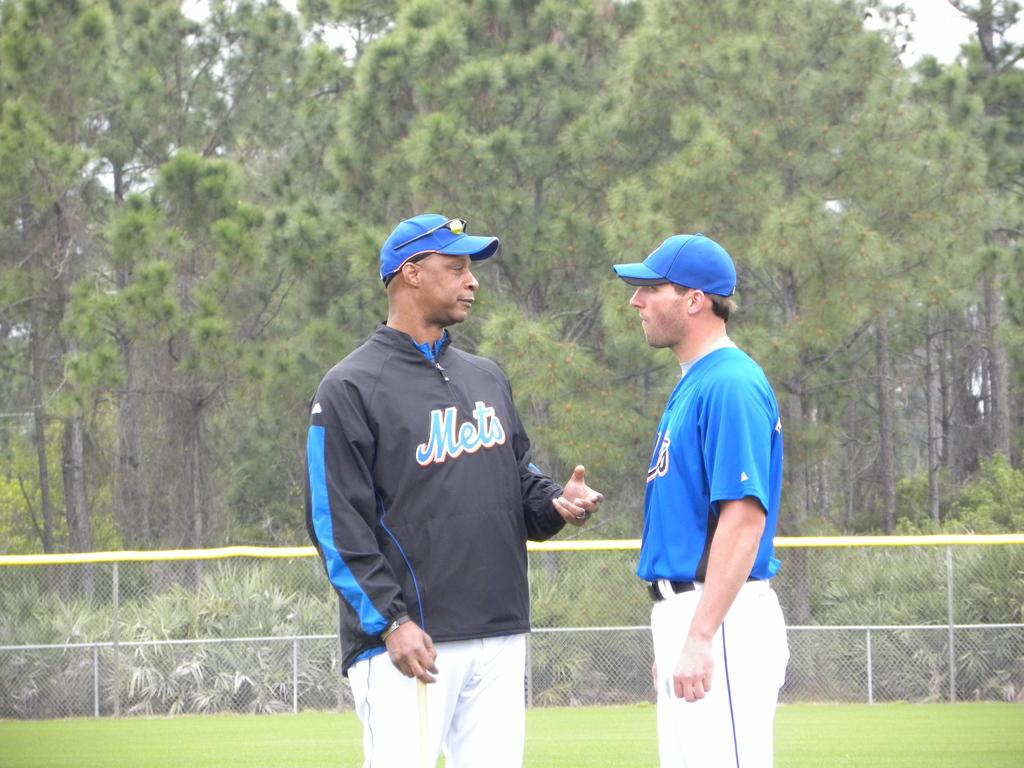<image>
Describe the image concisely. Two baseball players are talking together and one has Mets clearly written on his shirt. 